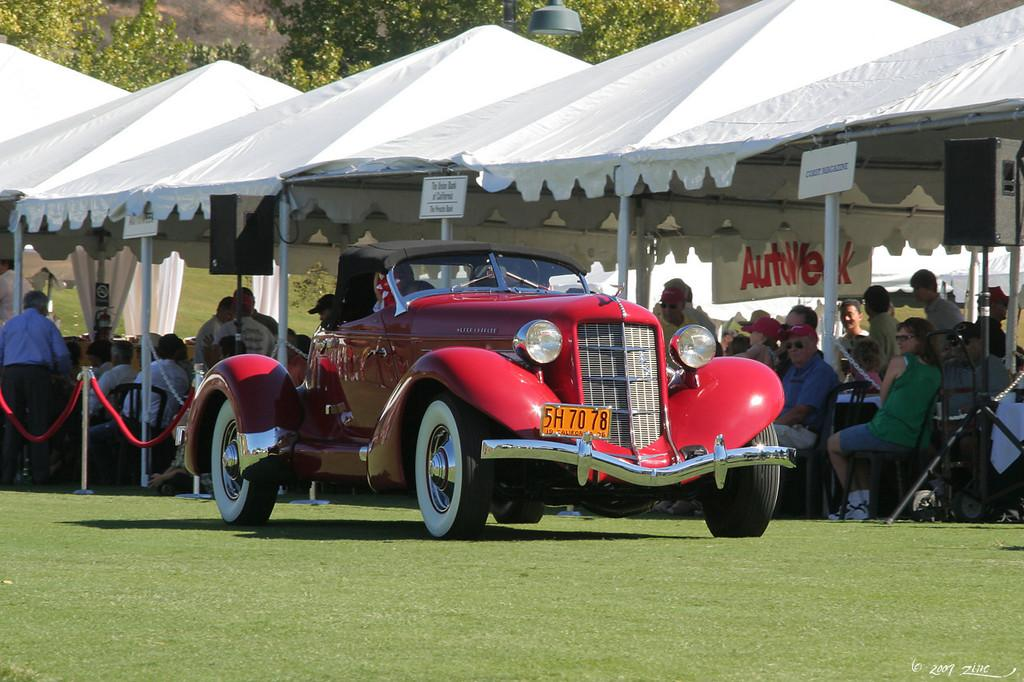What is the main object in the image? There is a vehicle in the image. Where is the vehicle located? The vehicle is on the ground. What structures are visible behind the vehicle? There are tents behind the vehicle. Who is under the tents? There are people under the tents. What can be seen in the background of the image? There are trees in the background of the image. What type of comb is being used by the person in the image? There is no person using a comb in the image. What type of pipe is visible in the image? There is no pipe present in the image. 